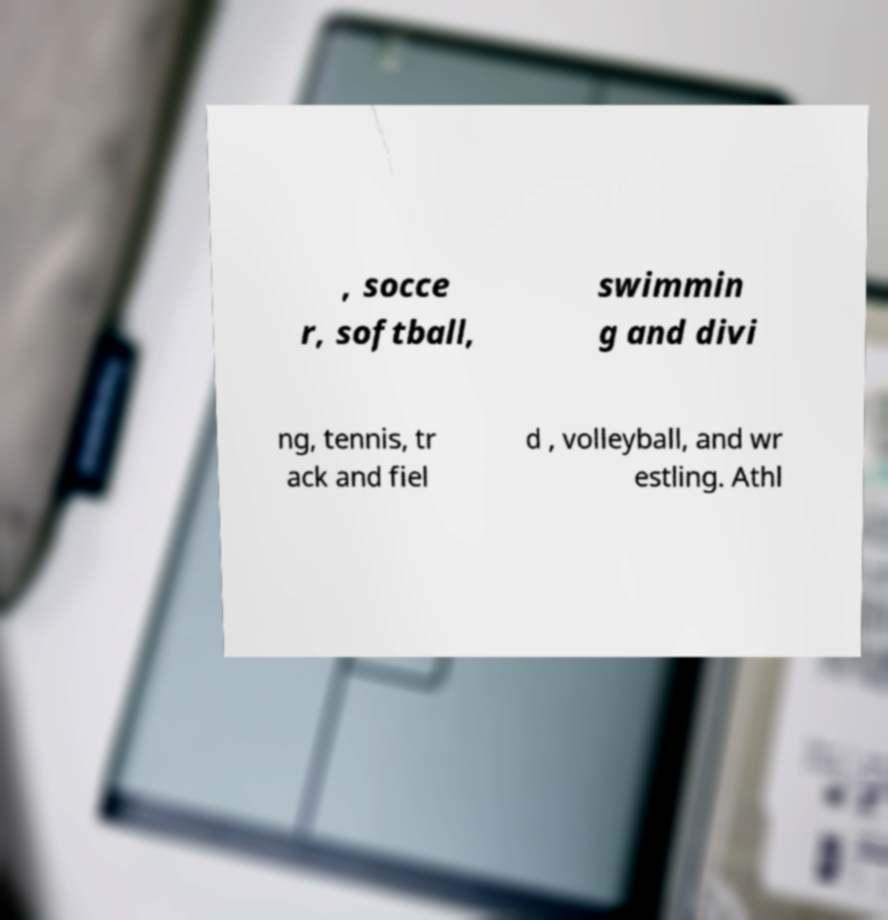Could you assist in decoding the text presented in this image and type it out clearly? , socce r, softball, swimmin g and divi ng, tennis, tr ack and fiel d , volleyball, and wr estling. Athl 